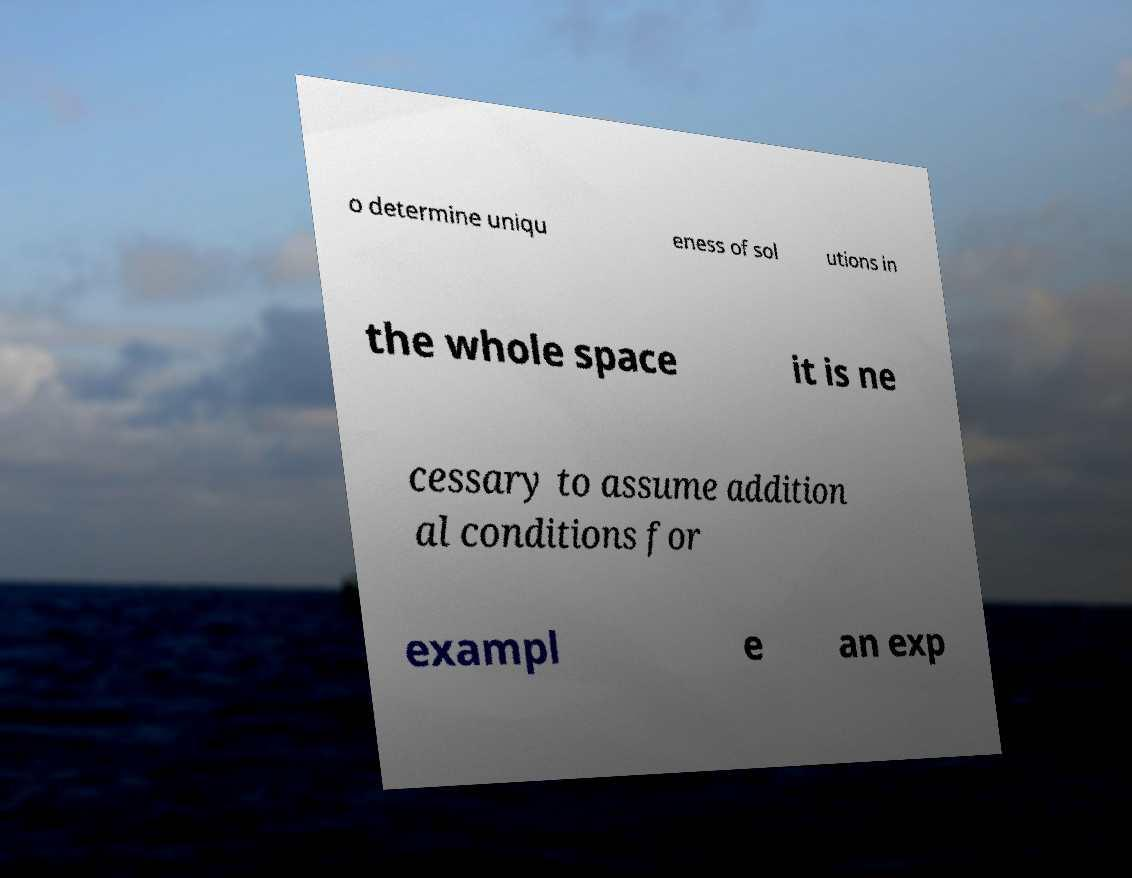Can you accurately transcribe the text from the provided image for me? o determine uniqu eness of sol utions in the whole space it is ne cessary to assume addition al conditions for exampl e an exp 